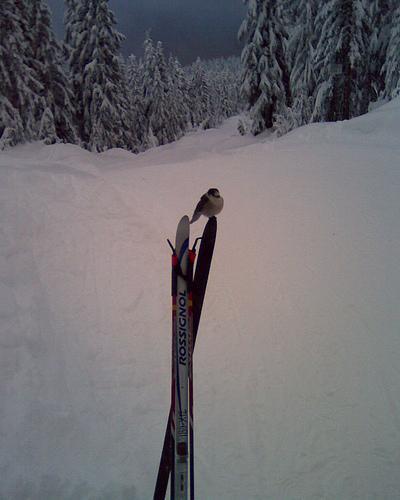How many people could sleep in this room?
Give a very brief answer. 0. 